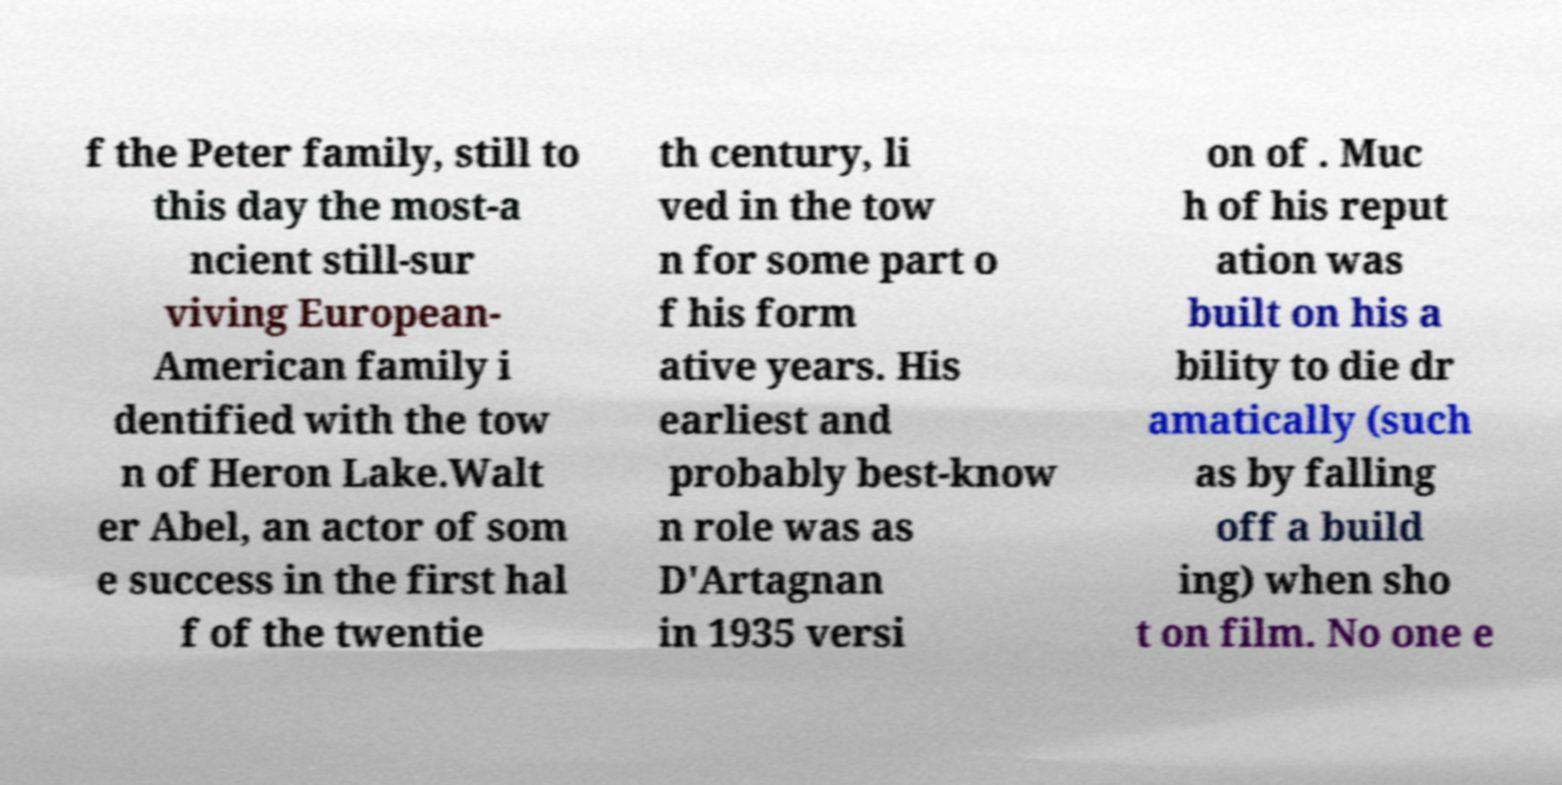For documentation purposes, I need the text within this image transcribed. Could you provide that? f the Peter family, still to this day the most-a ncient still-sur viving European- American family i dentified with the tow n of Heron Lake.Walt er Abel, an actor of som e success in the first hal f of the twentie th century, li ved in the tow n for some part o f his form ative years. His earliest and probably best-know n role was as D'Artagnan in 1935 versi on of . Muc h of his reput ation was built on his a bility to die dr amatically (such as by falling off a build ing) when sho t on film. No one e 